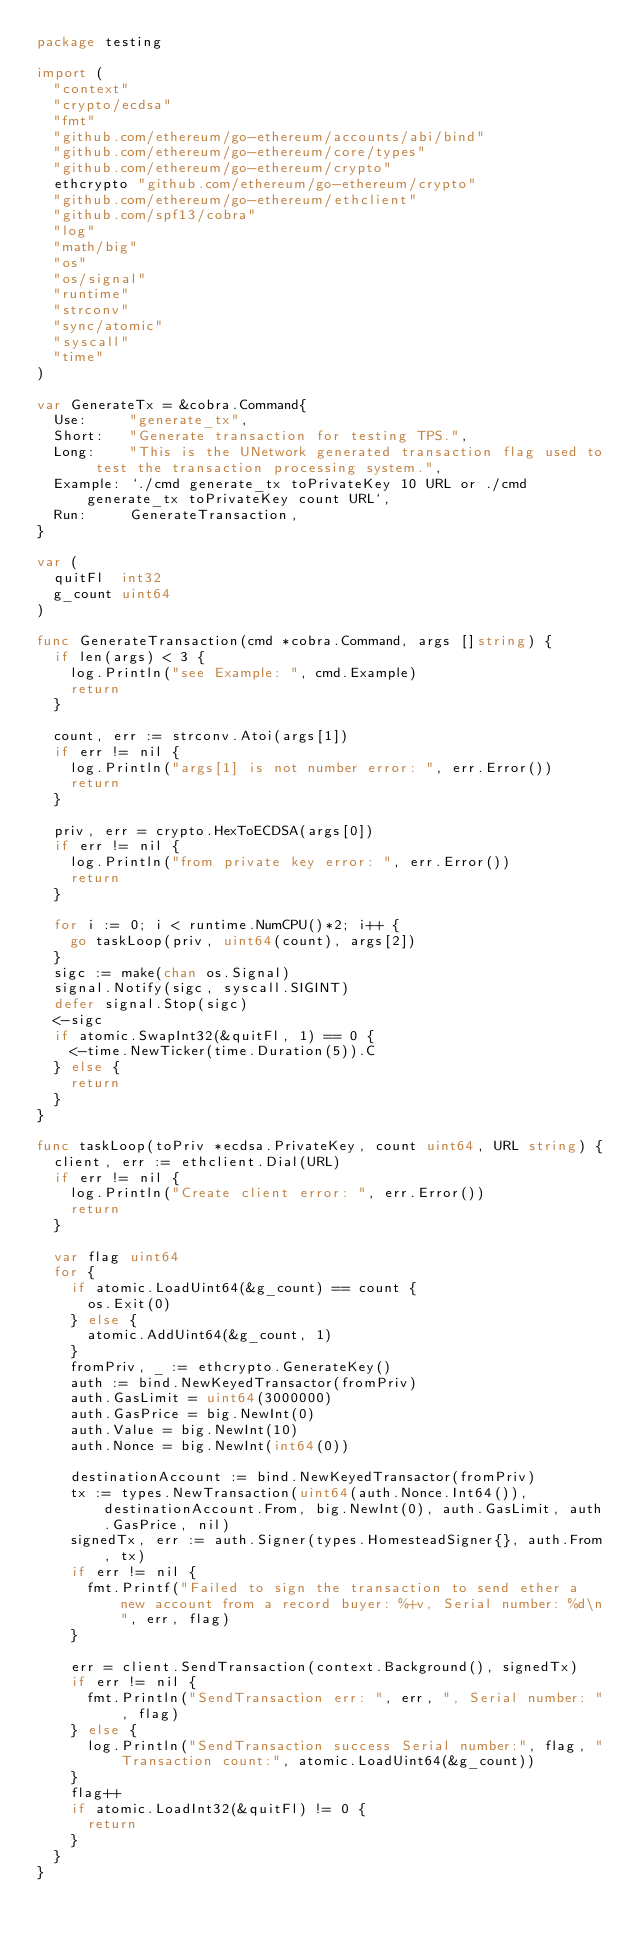<code> <loc_0><loc_0><loc_500><loc_500><_Go_>package testing

import (
	"context"
	"crypto/ecdsa"
	"fmt"
	"github.com/ethereum/go-ethereum/accounts/abi/bind"
	"github.com/ethereum/go-ethereum/core/types"
	"github.com/ethereum/go-ethereum/crypto"
	ethcrypto "github.com/ethereum/go-ethereum/crypto"
	"github.com/ethereum/go-ethereum/ethclient"
	"github.com/spf13/cobra"
	"log"
	"math/big"
	"os"
	"os/signal"
	"runtime"
	"strconv"
	"sync/atomic"
	"syscall"
	"time"
)

var GenerateTx = &cobra.Command{
	Use:     "generate_tx",
	Short:   "Generate transaction for testing TPS.",
	Long:    "This is the UNetwork generated transaction flag used to test the transaction processing system.",
	Example: `./cmd generate_tx toPrivateKey 10 URL or ./cmd generate_tx toPrivateKey count URL`,
	Run:     GenerateTransaction,
}

var (
	quitFl  int32
	g_count uint64
)

func GenerateTransaction(cmd *cobra.Command, args []string) {
	if len(args) < 3 {
		log.Println("see Example: ", cmd.Example)
		return
	}

	count, err := strconv.Atoi(args[1])
	if err != nil {
		log.Println("args[1] is not number error: ", err.Error())
		return
	}

	priv, err = crypto.HexToECDSA(args[0])
	if err != nil {
		log.Println("from private key error: ", err.Error())
		return
	}

	for i := 0; i < runtime.NumCPU()*2; i++ {
		go taskLoop(priv, uint64(count), args[2])
	}
	sigc := make(chan os.Signal)
	signal.Notify(sigc, syscall.SIGINT)
	defer signal.Stop(sigc)
	<-sigc
	if atomic.SwapInt32(&quitFl, 1) == 0 {
		<-time.NewTicker(time.Duration(5)).C
	} else {
		return
	}
}

func taskLoop(toPriv *ecdsa.PrivateKey, count uint64, URL string) {
	client, err := ethclient.Dial(URL)
	if err != nil {
		log.Println("Create client error: ", err.Error())
		return
	}

	var flag uint64
	for {
		if atomic.LoadUint64(&g_count) == count {
			os.Exit(0)
		} else {
			atomic.AddUint64(&g_count, 1)
		}
		fromPriv, _ := ethcrypto.GenerateKey()
		auth := bind.NewKeyedTransactor(fromPriv)
		auth.GasLimit = uint64(3000000)
		auth.GasPrice = big.NewInt(0)
		auth.Value = big.NewInt(10)
		auth.Nonce = big.NewInt(int64(0))

		destinationAccount := bind.NewKeyedTransactor(fromPriv)
		tx := types.NewTransaction(uint64(auth.Nonce.Int64()), destinationAccount.From, big.NewInt(0), auth.GasLimit, auth.GasPrice, nil)
		signedTx, err := auth.Signer(types.HomesteadSigner{}, auth.From, tx)
		if err != nil {
			fmt.Printf("Failed to sign the transaction to send ether a new account from a record buyer: %+v, Serial number: %d\n", err, flag)
		}

		err = client.SendTransaction(context.Background(), signedTx)
		if err != nil {
			fmt.Println("SendTransaction err: ", err, ", Serial number: ", flag)
		} else {
			log.Println("SendTransaction success Serial number:", flag, "Transaction count:", atomic.LoadUint64(&g_count))
		}
		flag++
		if atomic.LoadInt32(&quitFl) != 0 {
			return
		}
	}
}
</code> 